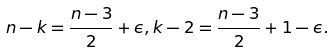<formula> <loc_0><loc_0><loc_500><loc_500>n - k = \frac { n - 3 } 2 + \epsilon , k - 2 = \frac { n - 3 } 2 + 1 - \epsilon .</formula> 